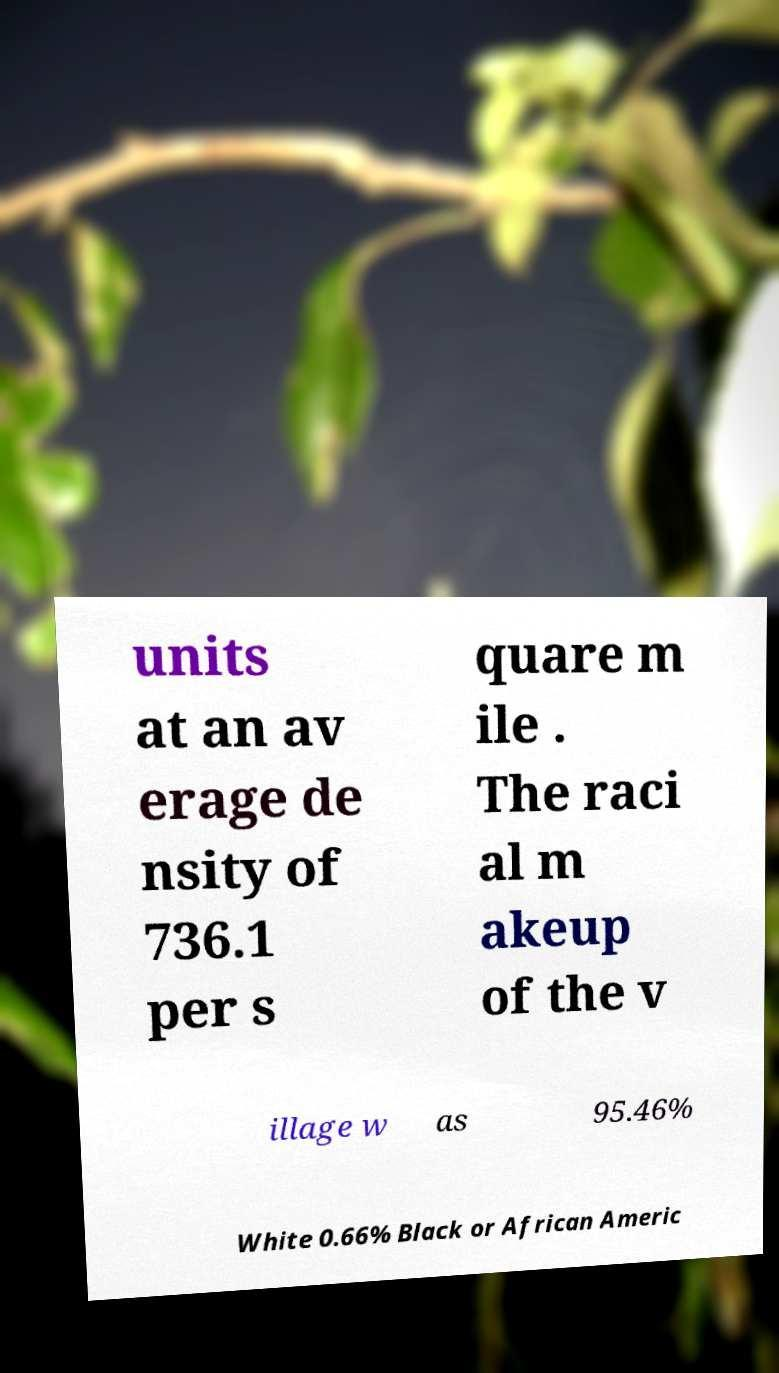What messages or text are displayed in this image? I need them in a readable, typed format. units at an av erage de nsity of 736.1 per s quare m ile . The raci al m akeup of the v illage w as 95.46% White 0.66% Black or African Americ 